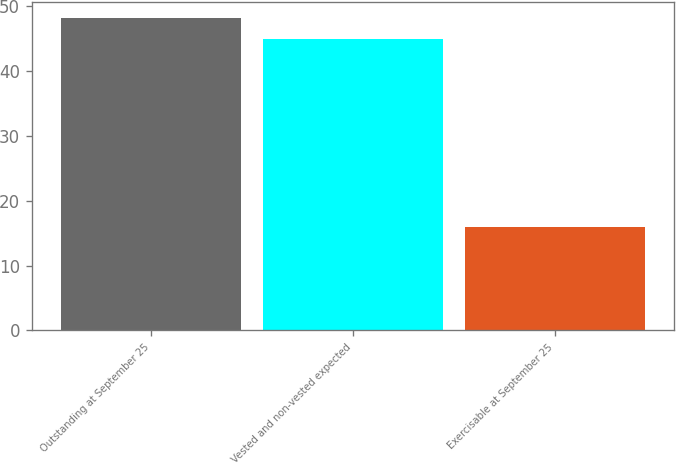Convert chart. <chart><loc_0><loc_0><loc_500><loc_500><bar_chart><fcel>Outstanding at September 25<fcel>Vested and non-vested expected<fcel>Exercisable at September 25<nl><fcel>48.2<fcel>45<fcel>16<nl></chart> 